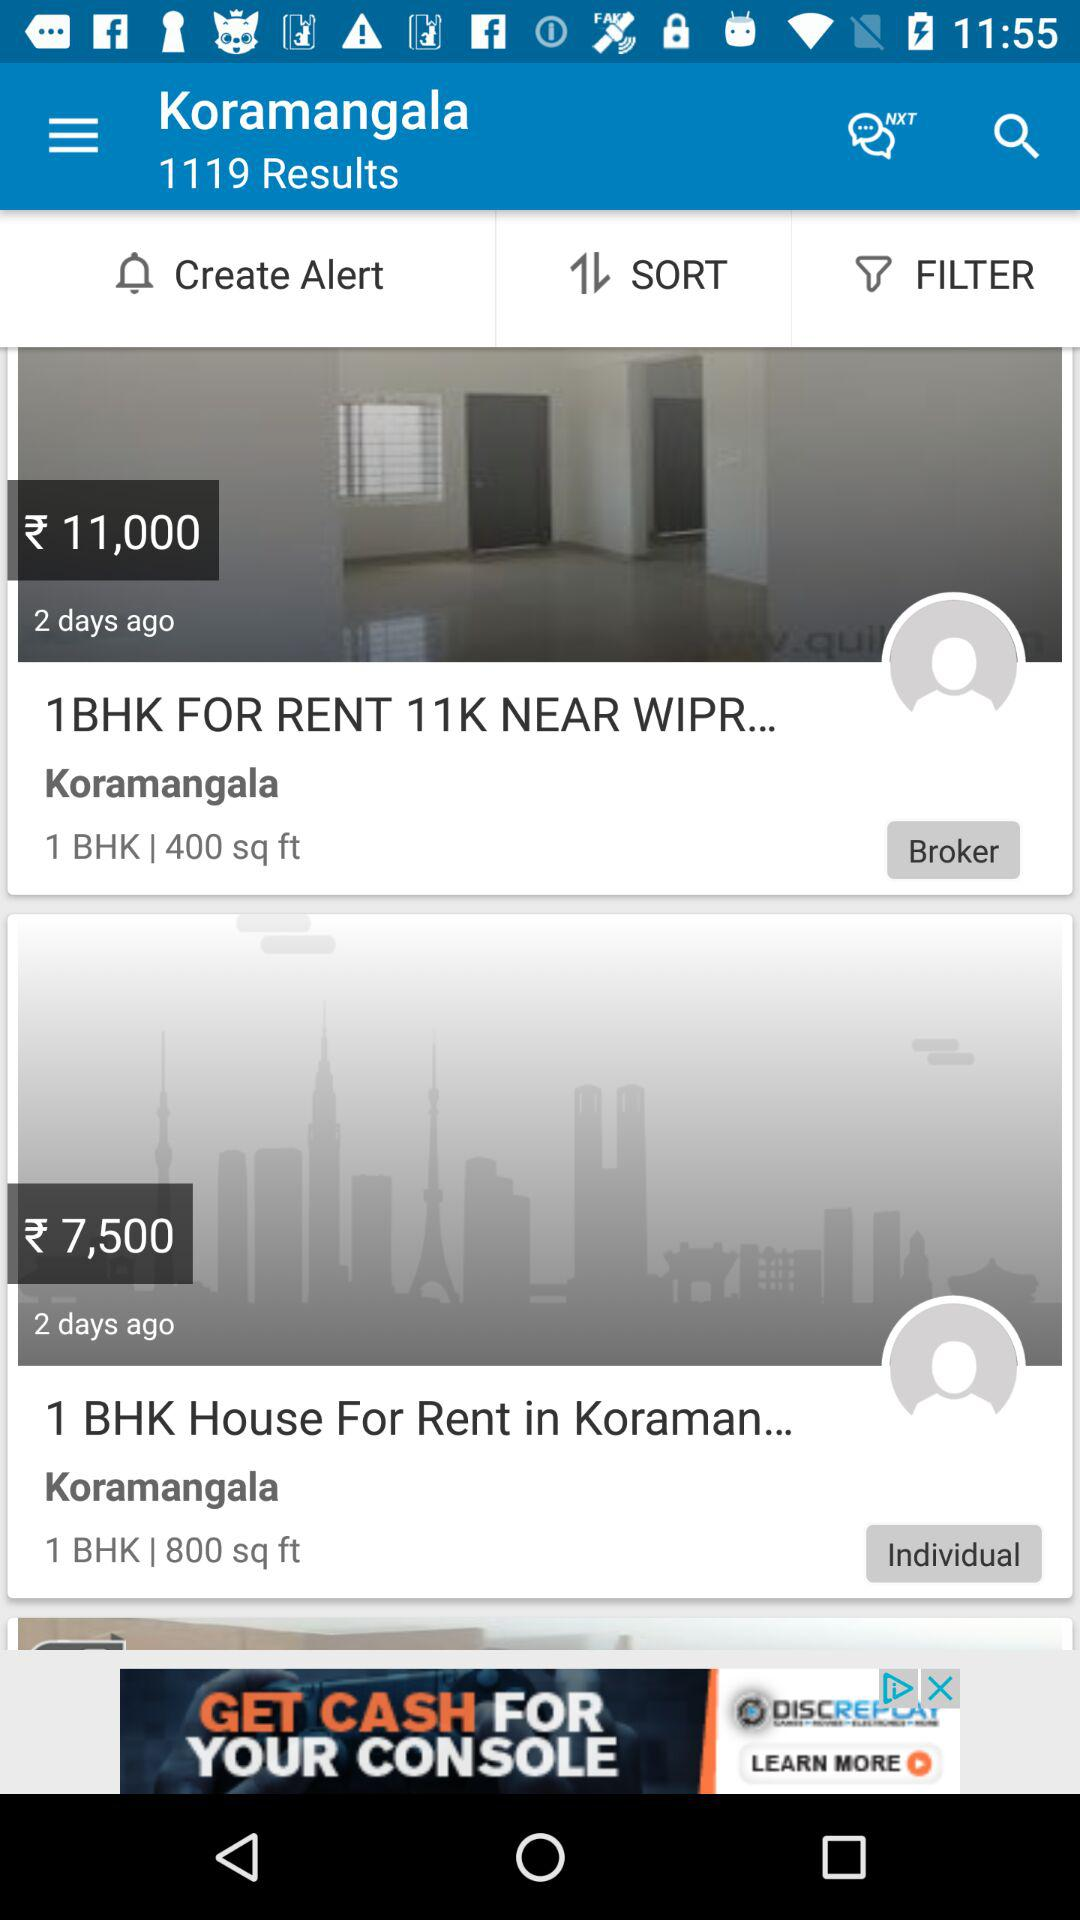What is the area of the rooms? The rooms are 400 and 800 square feet in size. 